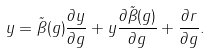Convert formula to latex. <formula><loc_0><loc_0><loc_500><loc_500>y = \tilde { \beta } ( g ) \frac { \partial y } { \partial g } + y \frac { \partial \tilde { \beta } ( g ) } { \partial g } + \frac { \partial r } { \partial g } .</formula> 